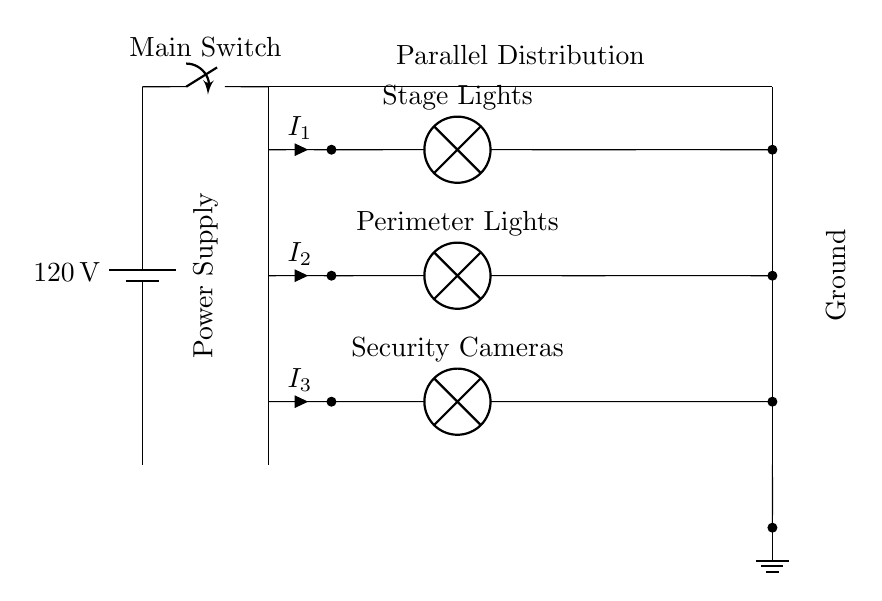What is the total voltage supplied to the circuit? The circuit is powered by a battery, which is indicated as supplying a voltage of 120 volts. This is shown at the power source on the left side of the circuit diagram.
Answer: 120 volts How many branches does this circuit have? The circuit diagram explicitly shows three distinct branches connected in parallel: Stage Lighting, Perimeter Lighting, and Security Cameras. Each branch's lighting component is individually indicated, signifying three separate paths for current.
Answer: Three What is the current in the Stage Lighting branch? The current in the Stage Lighting branch is labeled as I1 in the circuit diagram. This is represented by a label next to the path of the stage lights, specifically showing that this current is flowing through that particular branch.
Answer: I1 What type of circuit is shown in the diagram? The diagram represents a parallel circuit, which can be discerned from the arrangement of multiple branches connecting directly to the same two points of the power source, allowing each to operate independently from one another.
Answer: Parallel Why is a parallel circuit choice important for security lighting? A parallel circuit allows each lighting component to be powered independently. If one branch fails, the others remain operational, ensuring that lights and cameras continue functioning. This is particularly crucial for security measures around campaign venues.
Answer: Reliability 